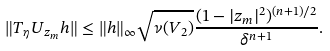Convert formula to latex. <formula><loc_0><loc_0><loc_500><loc_500>\| T _ { \eta } U _ { z _ { m } } h \| \leq \| h \| _ { \infty } \sqrt { \nu ( V _ { 2 } ) } \frac { ( 1 - | z _ { m } | ^ { 2 } ) ^ { ( n + 1 ) / 2 } } { \delta ^ { n + 1 } } .</formula> 